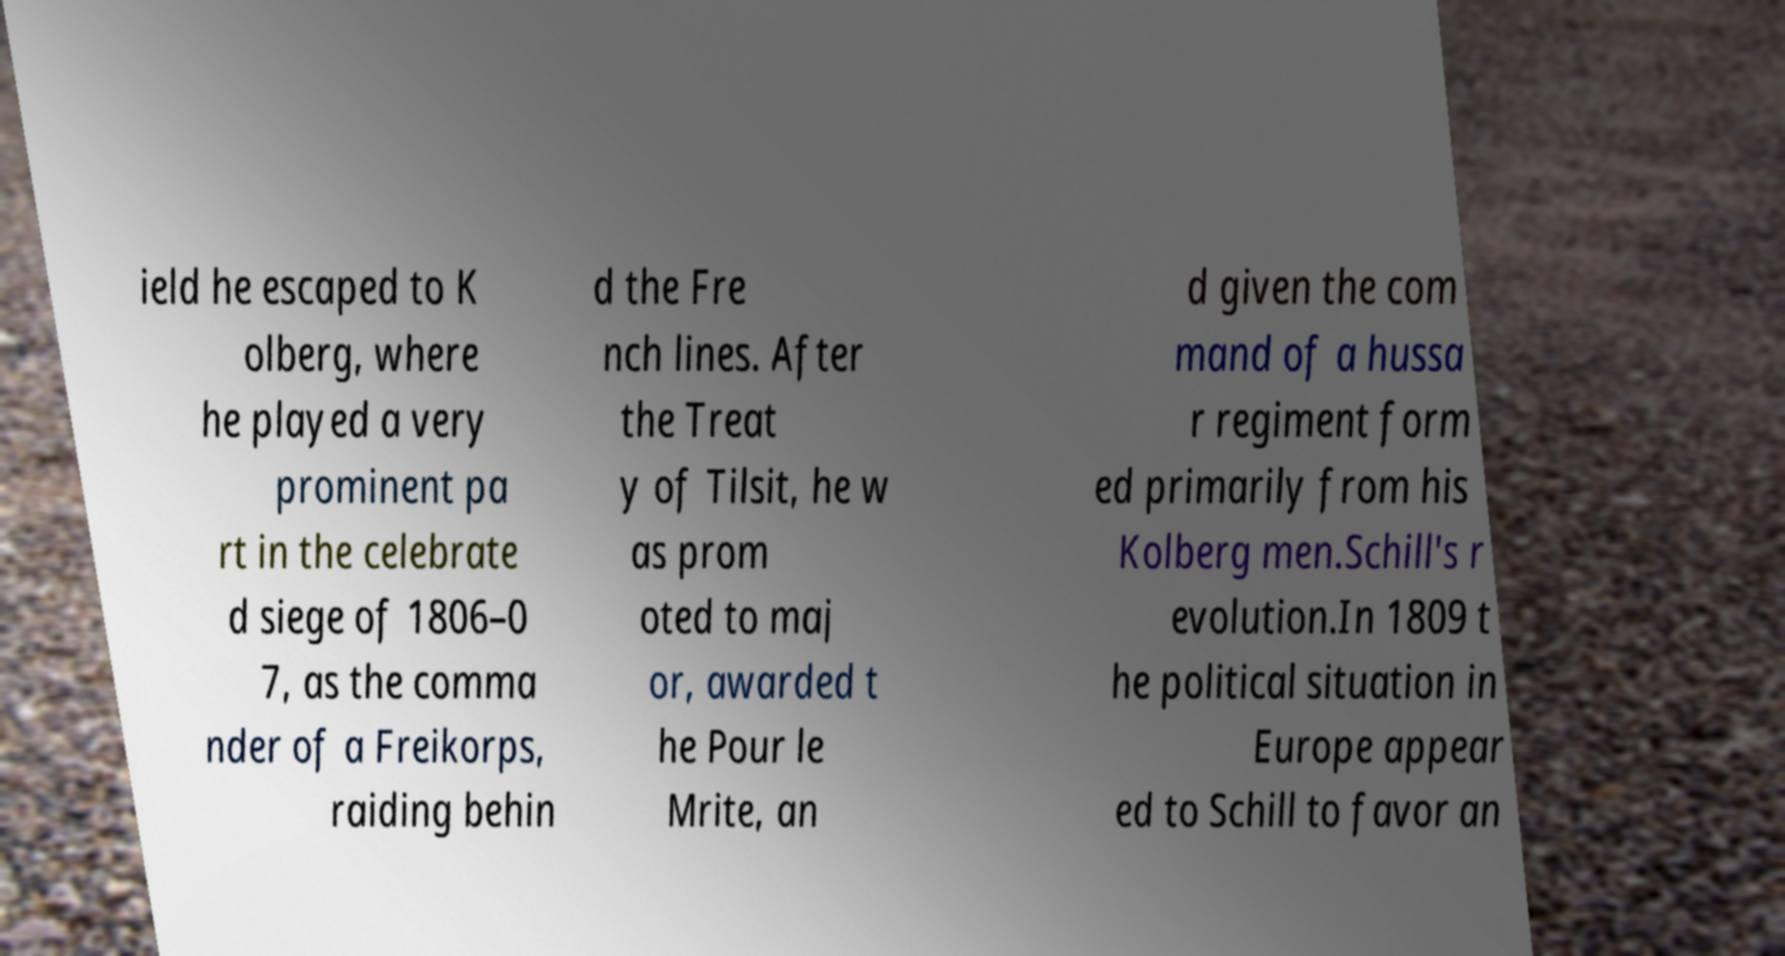Can you accurately transcribe the text from the provided image for me? ield he escaped to K olberg, where he played a very prominent pa rt in the celebrate d siege of 1806–0 7, as the comma nder of a Freikorps, raiding behin d the Fre nch lines. After the Treat y of Tilsit, he w as prom oted to maj or, awarded t he Pour le Mrite, an d given the com mand of a hussa r regiment form ed primarily from his Kolberg men.Schill's r evolution.In 1809 t he political situation in Europe appear ed to Schill to favor an 